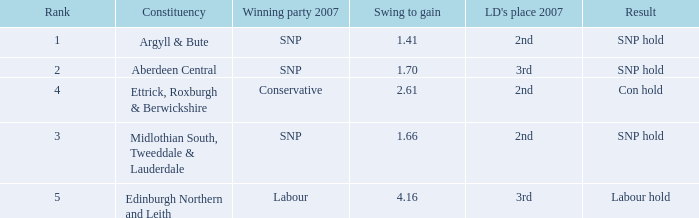What is the lowest rank when the constituency is edinburgh northern and leith and the swing to gain is less than 4.16? None. 